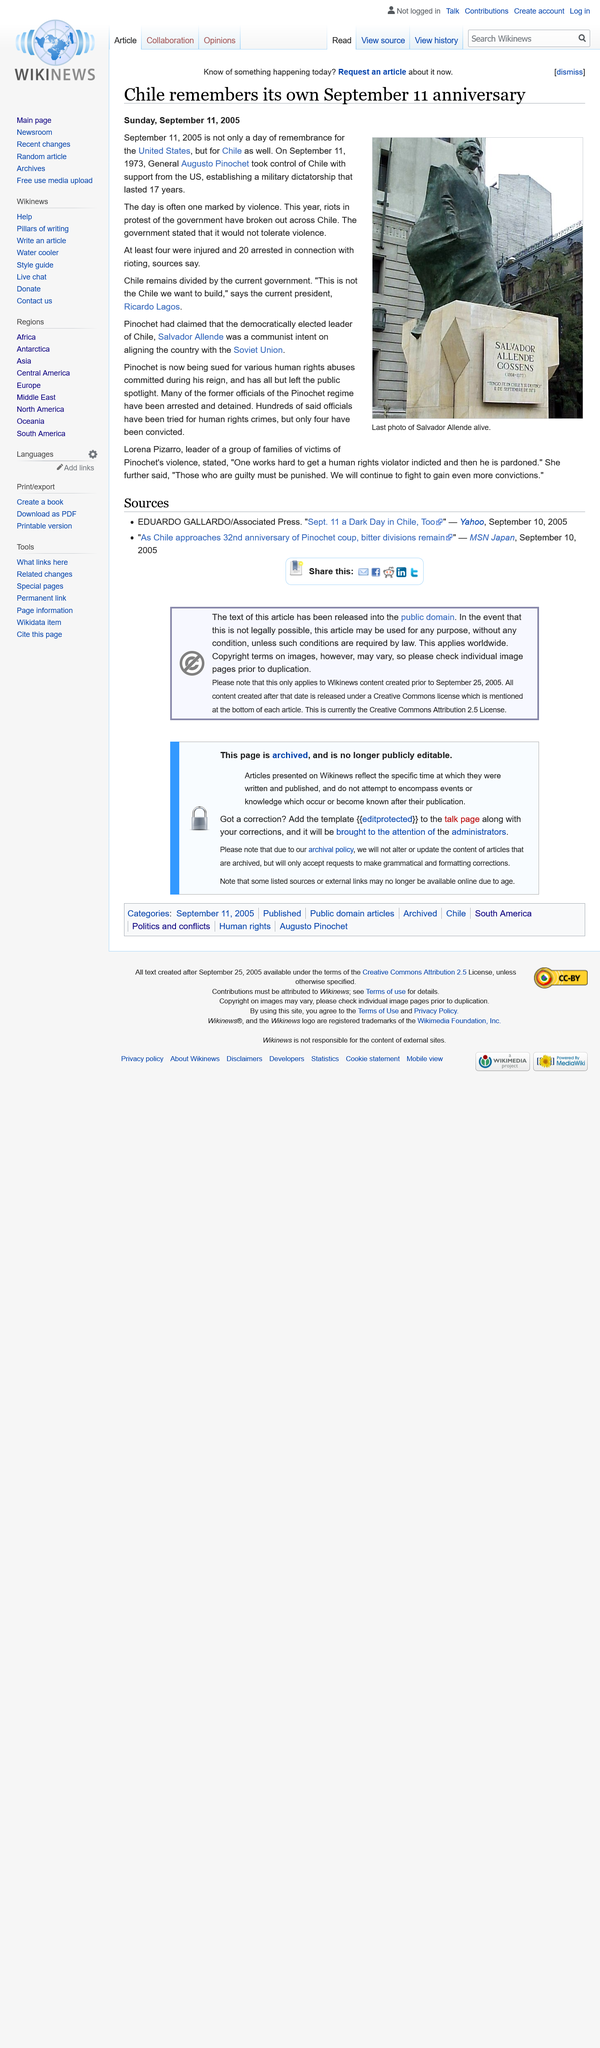Draw attention to some important aspects in this diagram. The sources used in the article were published on September 10th, 2005. The image depicts the final photograph of Salvador Allende, who was alive at the time of its capture. On September 11, 1973, General Pinochet led a military coup in Chile, which is remembered in Chile to this day. Pinochet is being sued for his involvement in numerous human rights abuses. On September 11, 2005, there were widespread riots in Chile protesting against the government, resulting in significant unrest across the country. 